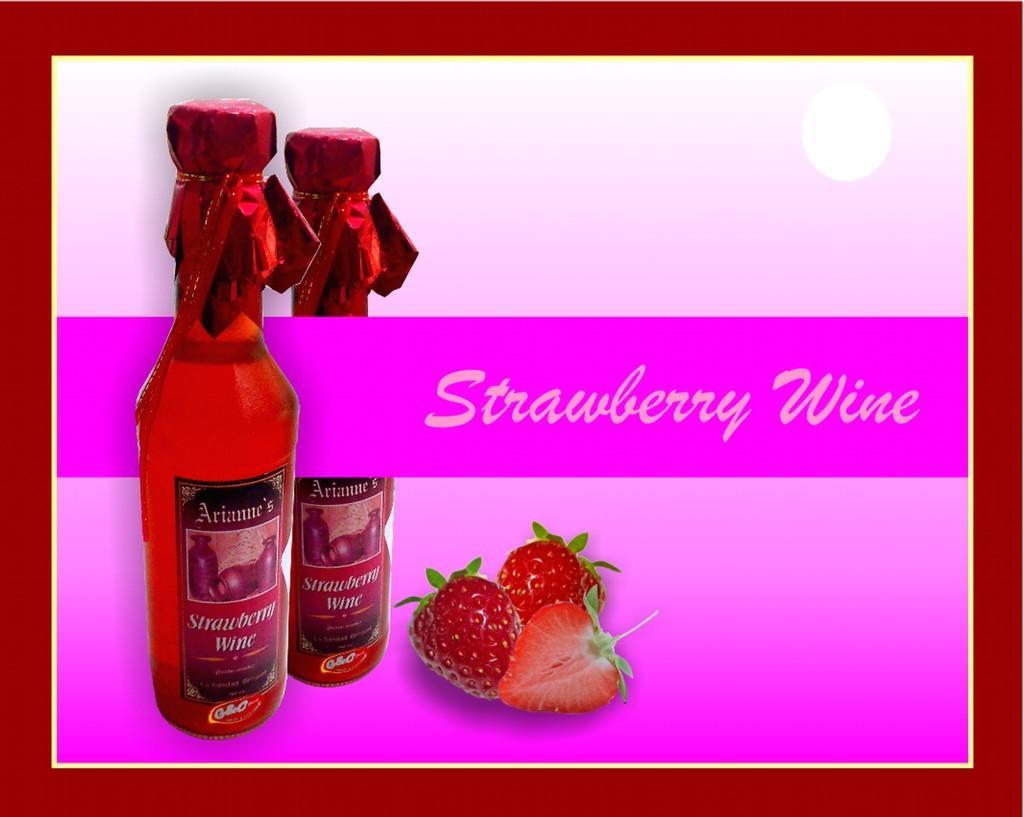In one or two sentences, can you explain what this image depicts? This is a poster. In this image there are pictures of bottles and strawberries and there is text. 